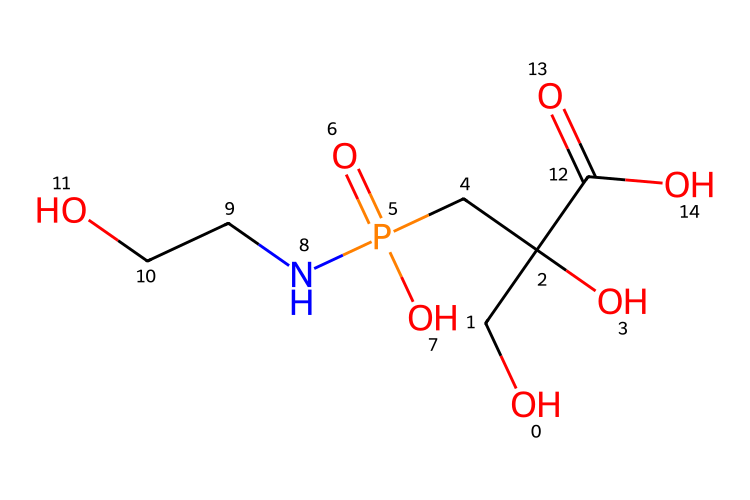What is the molecular weight of this chemical? To find the molecular weight, we add up the atomic weights of each atom in the SMILES representation. The atoms include carbon (C), hydrogen (H), oxygen (O), and phosphorus (P). Counting from the structure gives: 5 C, 11 H, 4 O, and 1 P. Thus, the molecular weight calculation is (5*12.01) + (11*1.008) + (4*16.00) + (1*30.97) = 169.07 g/mol.
Answer: 169.07 g/mol How many oxygen atoms are present in the structure? By examining the SMILES representation, we can see the presence of oxygen atoms signified by the letter "O". Counting reveals a total of 4 oxygen atoms in the structure.
Answer: 4 What type of pesticide is glyphosate classified as? Glyphosate is primarily classified as a broad-spectrum systemic herbicide. This classification is based on its chemical composition and how it functions to control weeds.
Answer: herbicide What functional groups can be identified in this chemical? Functional groups can be identified by looking at specific arrangements in the SMILES notation. Here, several functional groups appear: a carboxylic group (-COOH), an amine group (-NH), and a phosphonic acid group (-PO3H2). Therefore, the answer includes these functional groups present.
Answer: carboxylic, amine, phosphonic How does glyphosate interact with plants? Glyphosate works by inhibiting a specific pathway (the shikimic acid pathway) essential for plant growth. This mechanism is a result of its chemical structure, which allows it to enter plant cells and affect metabolic processes. Thus, the interaction results from its ability to target specific biochemical pathways in plants.
Answer: inhibition of shikimic pathway What is the main purpose of glyphosate in urban landscaping? Glyphosate is mainly used for weed control in urban landscaping. Its effectiveness in killing many types of weeds makes it a popular choice among gardeners and landscapers.
Answer: weed control 